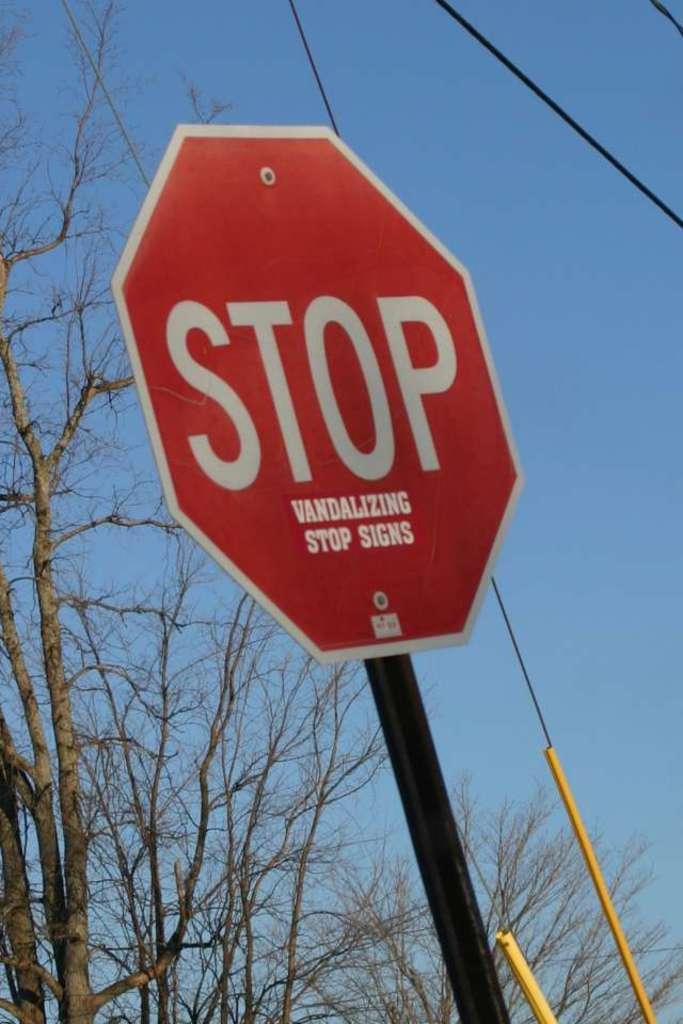What is this red sign say?
Offer a terse response. Stop vandalizing stop signs. Does this sign tell you which way to go?
Provide a succinct answer. No. 